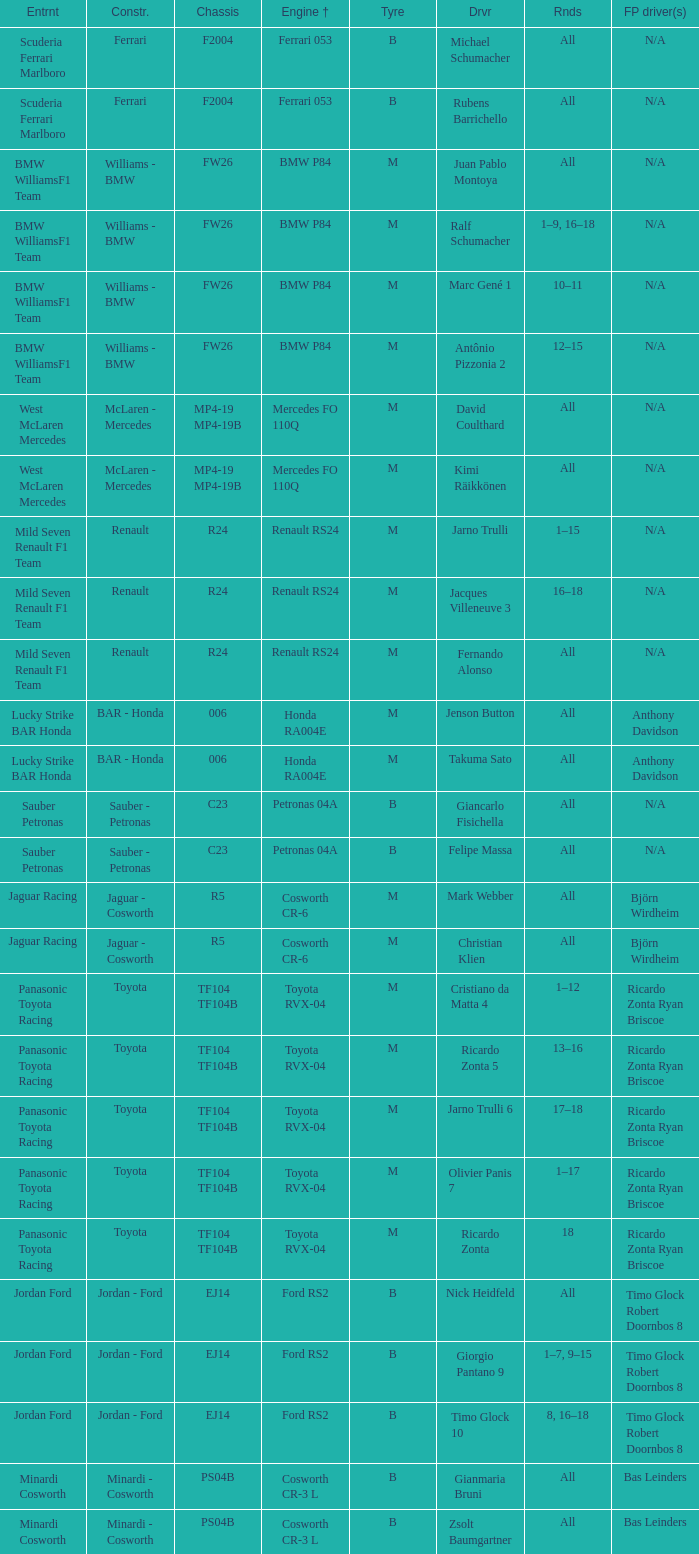What kind of chassis does Ricardo Zonta have? TF104 TF104B. 